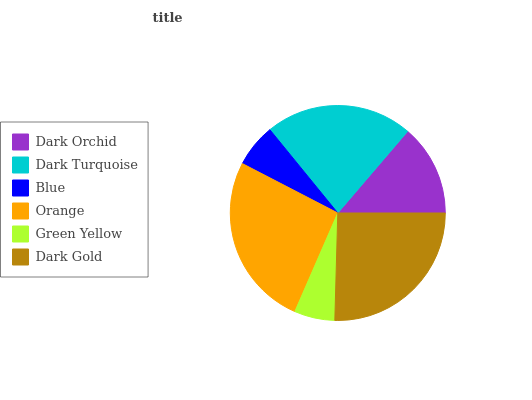Is Green Yellow the minimum?
Answer yes or no. Yes. Is Orange the maximum?
Answer yes or no. Yes. Is Dark Turquoise the minimum?
Answer yes or no. No. Is Dark Turquoise the maximum?
Answer yes or no. No. Is Dark Turquoise greater than Dark Orchid?
Answer yes or no. Yes. Is Dark Orchid less than Dark Turquoise?
Answer yes or no. Yes. Is Dark Orchid greater than Dark Turquoise?
Answer yes or no. No. Is Dark Turquoise less than Dark Orchid?
Answer yes or no. No. Is Dark Turquoise the high median?
Answer yes or no. Yes. Is Dark Orchid the low median?
Answer yes or no. Yes. Is Orange the high median?
Answer yes or no. No. Is Blue the low median?
Answer yes or no. No. 